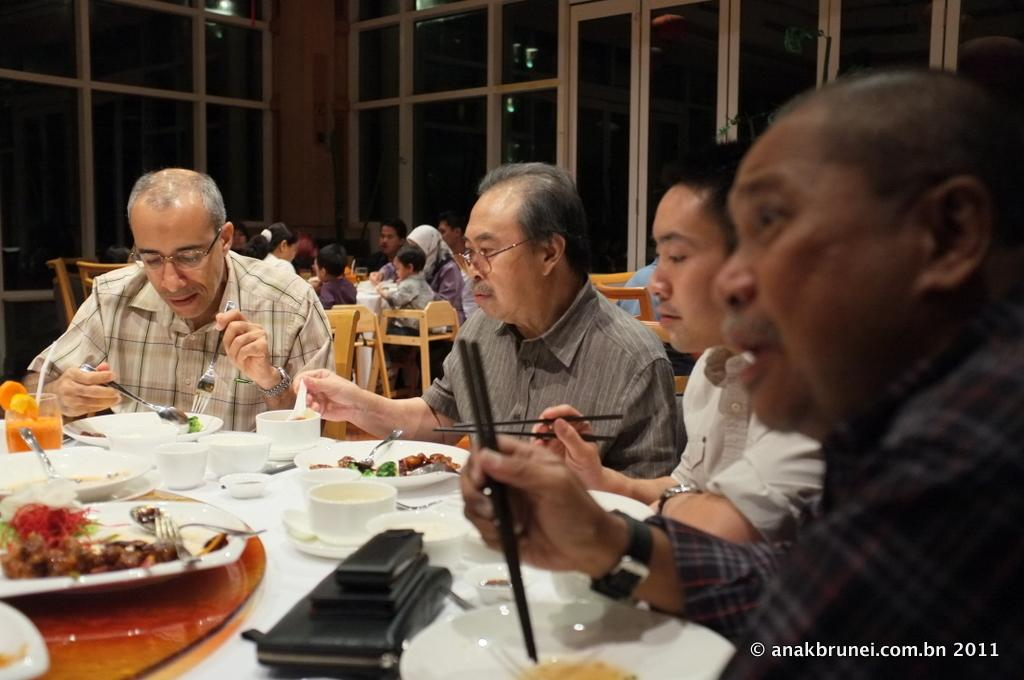What objects are on the table in the image? There are plates and bowls on the table in the image. Who or what is present in the image? There are people in the image. What can be seen in the background of the image? There are windows visible in the background of the image. Where is the goose resting in the image? There is no goose present in the image, so it cannot be resting in the image. 